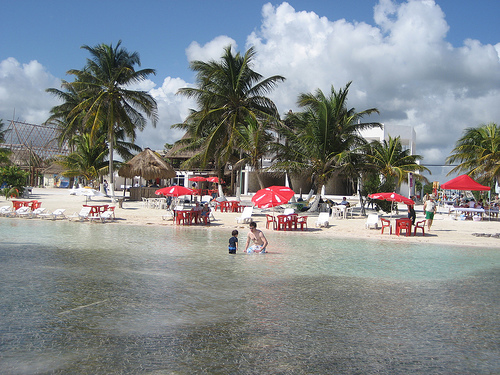<image>
Is there a man behind the water? No. The man is not behind the water. From this viewpoint, the man appears to be positioned elsewhere in the scene. 